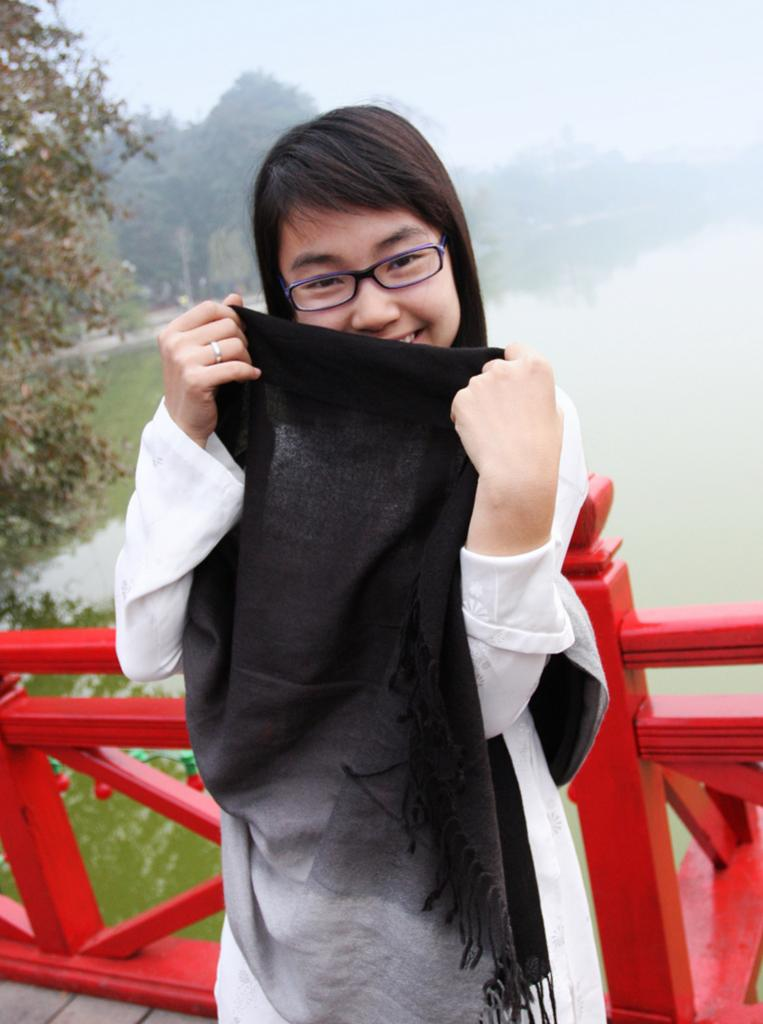Who is present in the image? There is a woman in the image. What is the woman doing in the image? The woman is standing on a bridge. What can be seen below the bridge in the image? There is a water surface visible in the image. What is the surrounding environment like in the image? There are many trees around the water surface. What type of coal can be seen in the woman's eyes in the image? There is no coal or reference to the woman's eyes in the image. 